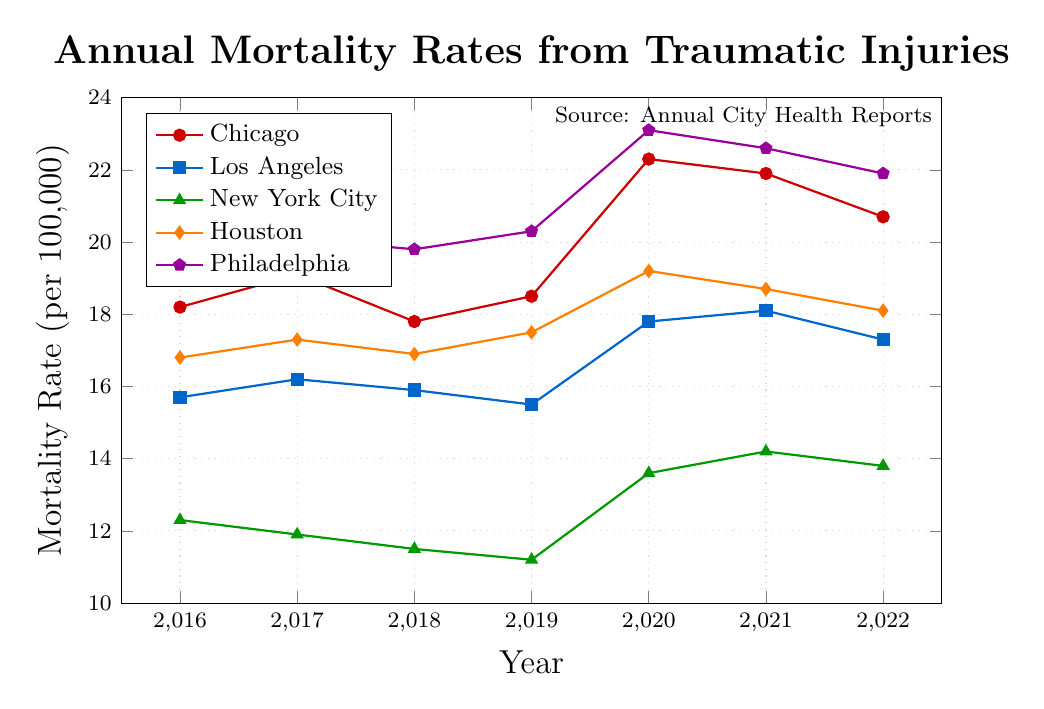What is the mortality rate trend for Chicago from 2016 to 2022? To determine the trend, observe the mortality rates for Chicago each year from 2016 to 2022. The rates are 18.2, 19.1, 17.8, 18.5, 22.3, 21.9, and 20.7 respectively. The trend shows an initial increase, followed by a slight decrease, a spike in 2020, and a gradual decline thereafter.
Answer: Initial increase, followed by a slight decrease, a spike in 2020, and a gradual decline Which city had the lowest mortality rate in 2019? Check the mortality rates for all listed cities in 2019. The rates are Chicago: 18.5, Los Angeles: 15.5, New York City: 11.2, Houston: 17.5, and Philadelphia: 20.3. New York City has the lowest rate at 11.2.
Answer: New York City By how much did the mortality rate change in Los Angeles from 2018 to 2022? Identify the mortality rates for Los Angeles in 2018 and 2022, which are 15.9 and 17.3 respectively. The change is calculated as 17.3 - 15.9 = 1.4.
Answer: 1.4 Between 2020 and 2021, which city experienced the greatest decrease in mortality rate? Check the mortality rates for all cities in 2020 and 2021. Calculate the differences: Chicago: 22.3 - 21.9 = 0.4, Los Angeles: 17.8 - 18.1 = -0.3 (increase), New York City: 13.6 - 14.2 = -0.6 (increase), Houston: 19.2 - 18.7 = 0.5, Philadelphia: 23.1 - 22.6 = 0.5. Chicago had the greatest decrease at 0.4.
Answer: Chicago What is the overall average mortality rate for New York City from 2016 to 2022? Find the sum of the mortality rates for New York City from 2016 to 2022: 12.3 + 11.9 + 11.5 + 11.2 + 13.6 + 14.2 + 13.8 = 88.5. Divide by the number of years, 88.5 / 7 ≈ 12.64.
Answer: 12.64 Which city has shown the most overall stability in mortality rates from 2016 to 2022? Observe the fluctuations in mortality rates for each city from 2016 to 2022. Los Angeles shows relatively stable rates with small fluctuations: 15.7, 16.2, 15.9, 15.5, 17.8, 18.1, 17.3.
Answer: Los Angeles Compare the mortality rates in 2020 across all cities. Which city had the highest rate? List the mortality rates for all cities in 2020: Chicago: 22.3, Los Angeles: 17.8, New York City: 13.6, Houston: 19.2, Philadelphia: 23.1. Philadelphia has the highest rate at 23.1.
Answer: Philadelphia What is the difference in mortality rates between Houston and Philadelphia in 2022? Identify the mortality rates for Houston and Philadelphia in 2022, which are 18.1 and 21.9 respectively. The difference is calculated as 21.9 - 18.1 = 3.8.
Answer: 3.8 What is the average mortality rate across all cities in 2017? Calculate the sum of the mortality rates for all cities in 2017: 19.1 + 16.2 + 11.9 + 17.3 + 20.1 = 84.6. Divide by the number of cities, 84.6 / 5 = 16.92.
Answer: 16.92 